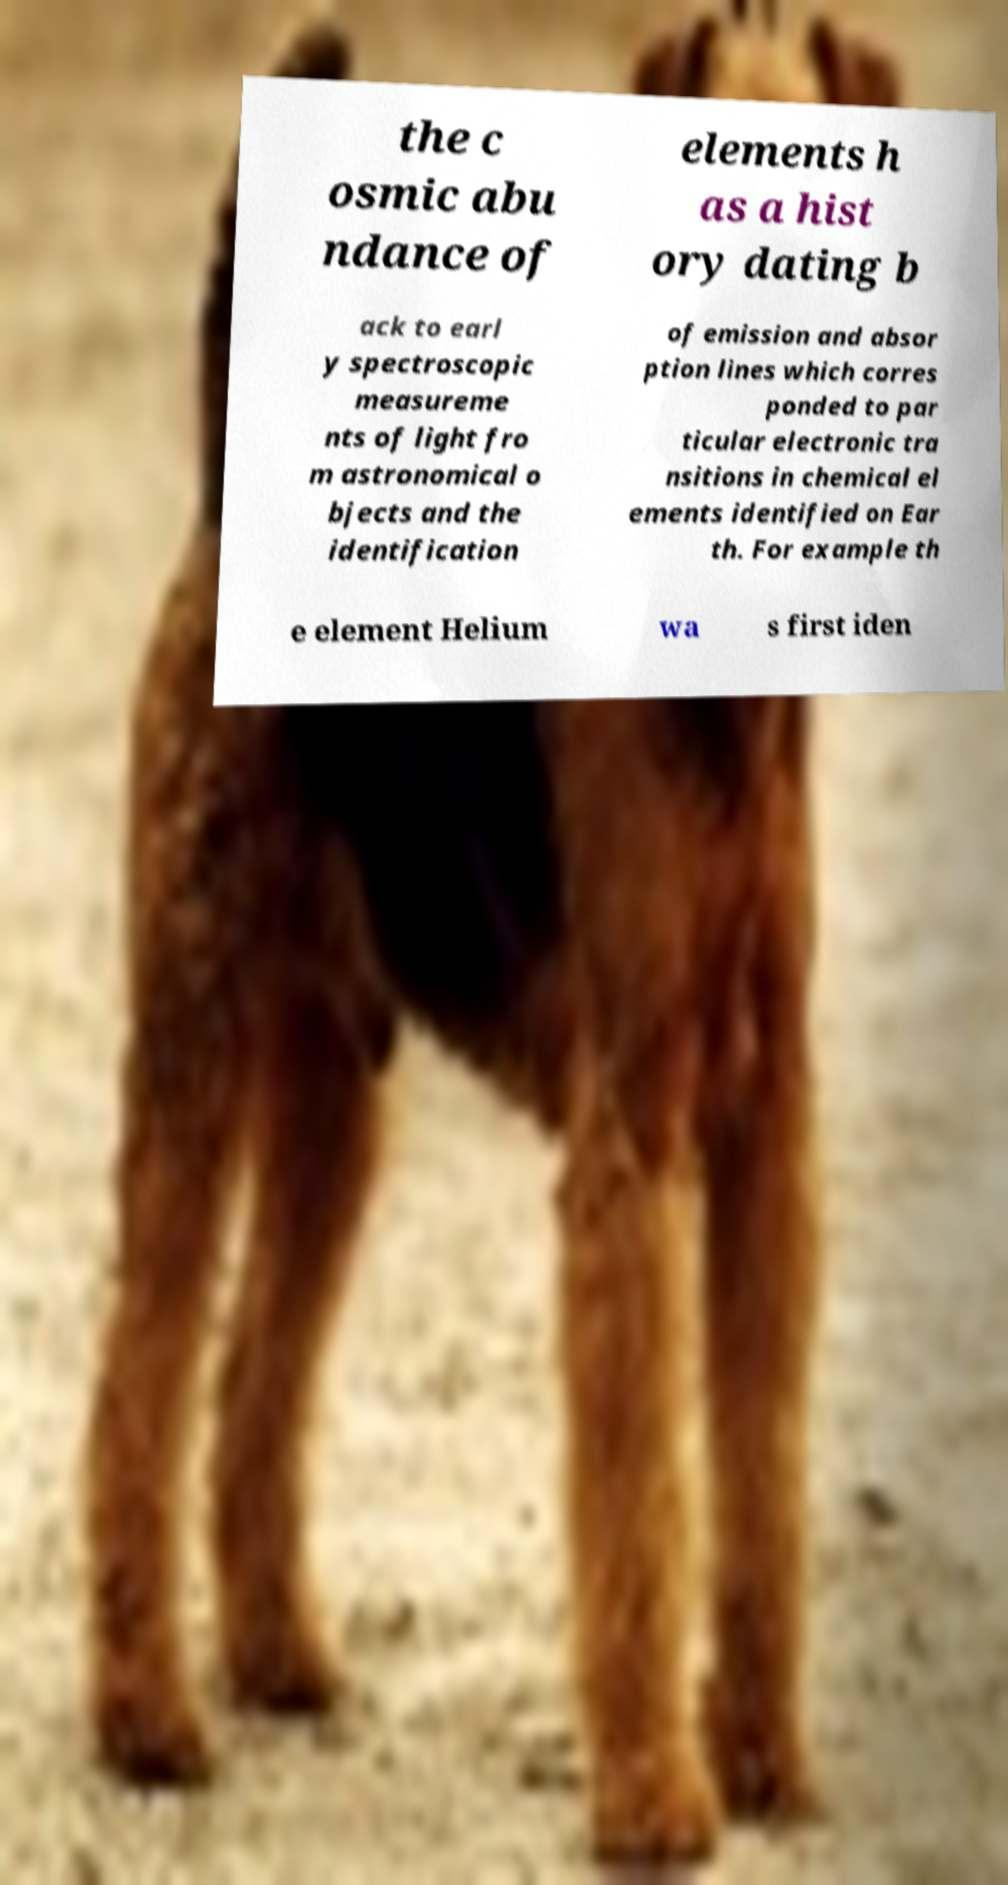There's text embedded in this image that I need extracted. Can you transcribe it verbatim? the c osmic abu ndance of elements h as a hist ory dating b ack to earl y spectroscopic measureme nts of light fro m astronomical o bjects and the identification of emission and absor ption lines which corres ponded to par ticular electronic tra nsitions in chemical el ements identified on Ear th. For example th e element Helium wa s first iden 